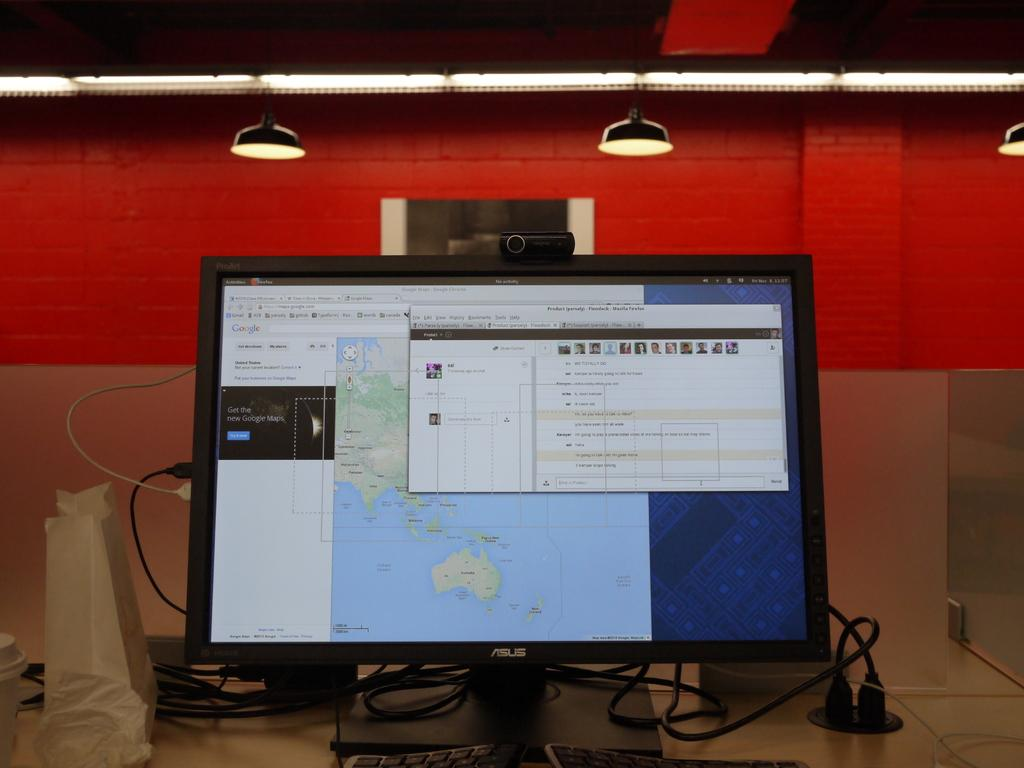<image>
Summarize the visual content of the image. Asus desktop computer with Mozilla Firefox webpage pulled up. 